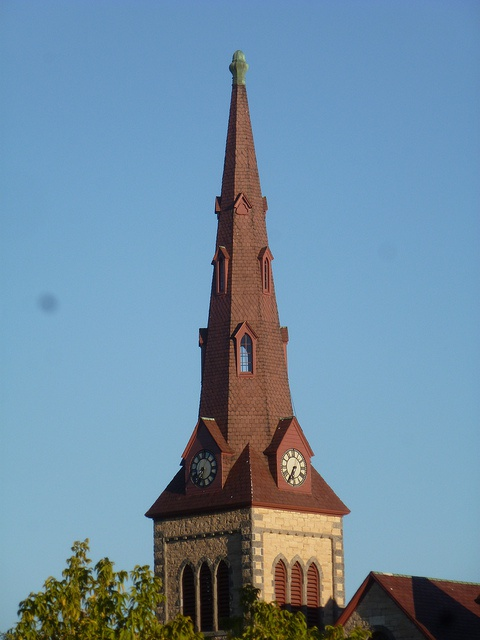Describe the objects in this image and their specific colors. I can see clock in gray, beige, and tan tones and clock in gray, black, purple, and darkblue tones in this image. 